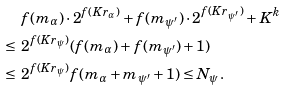<formula> <loc_0><loc_0><loc_500><loc_500>& f ( m _ { \alpha } ) \cdot 2 ^ { f ( K r _ { \alpha } ) } + f ( m _ { \psi ^ { \prime } } ) \cdot 2 ^ { f ( K r _ { \psi ^ { \prime } } ) } + K ^ { k } \\ \leq \ & 2 ^ { f ( K r _ { \psi } ) } ( f ( m _ { \alpha } ) + f ( m _ { \psi ^ { \prime } } ) + 1 ) \\ \leq \ & 2 ^ { f ( K r _ { \psi } ) } f ( m _ { \alpha } + m _ { \psi ^ { \prime } } + 1 ) \leq N _ { \psi } .</formula> 